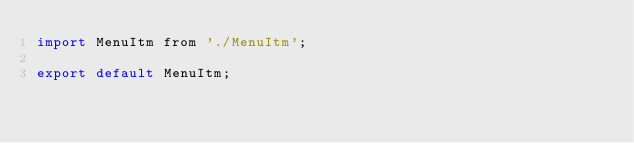Convert code to text. <code><loc_0><loc_0><loc_500><loc_500><_JavaScript_>import MenuItm from './MenuItm';

export default MenuItm;</code> 